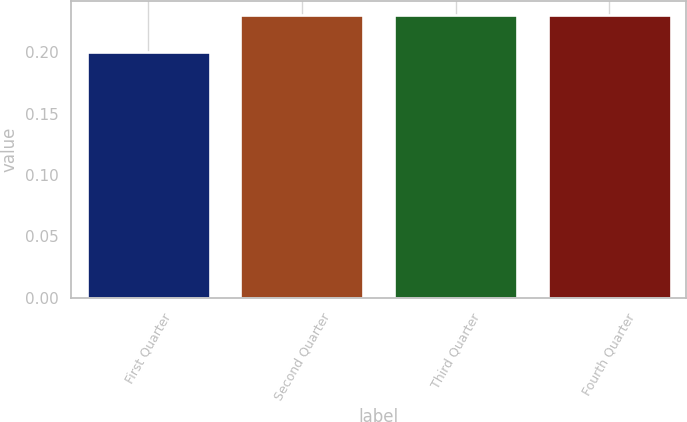<chart> <loc_0><loc_0><loc_500><loc_500><bar_chart><fcel>First Quarter<fcel>Second Quarter<fcel>Third Quarter<fcel>Fourth Quarter<nl><fcel>0.2<fcel>0.23<fcel>0.23<fcel>0.23<nl></chart> 